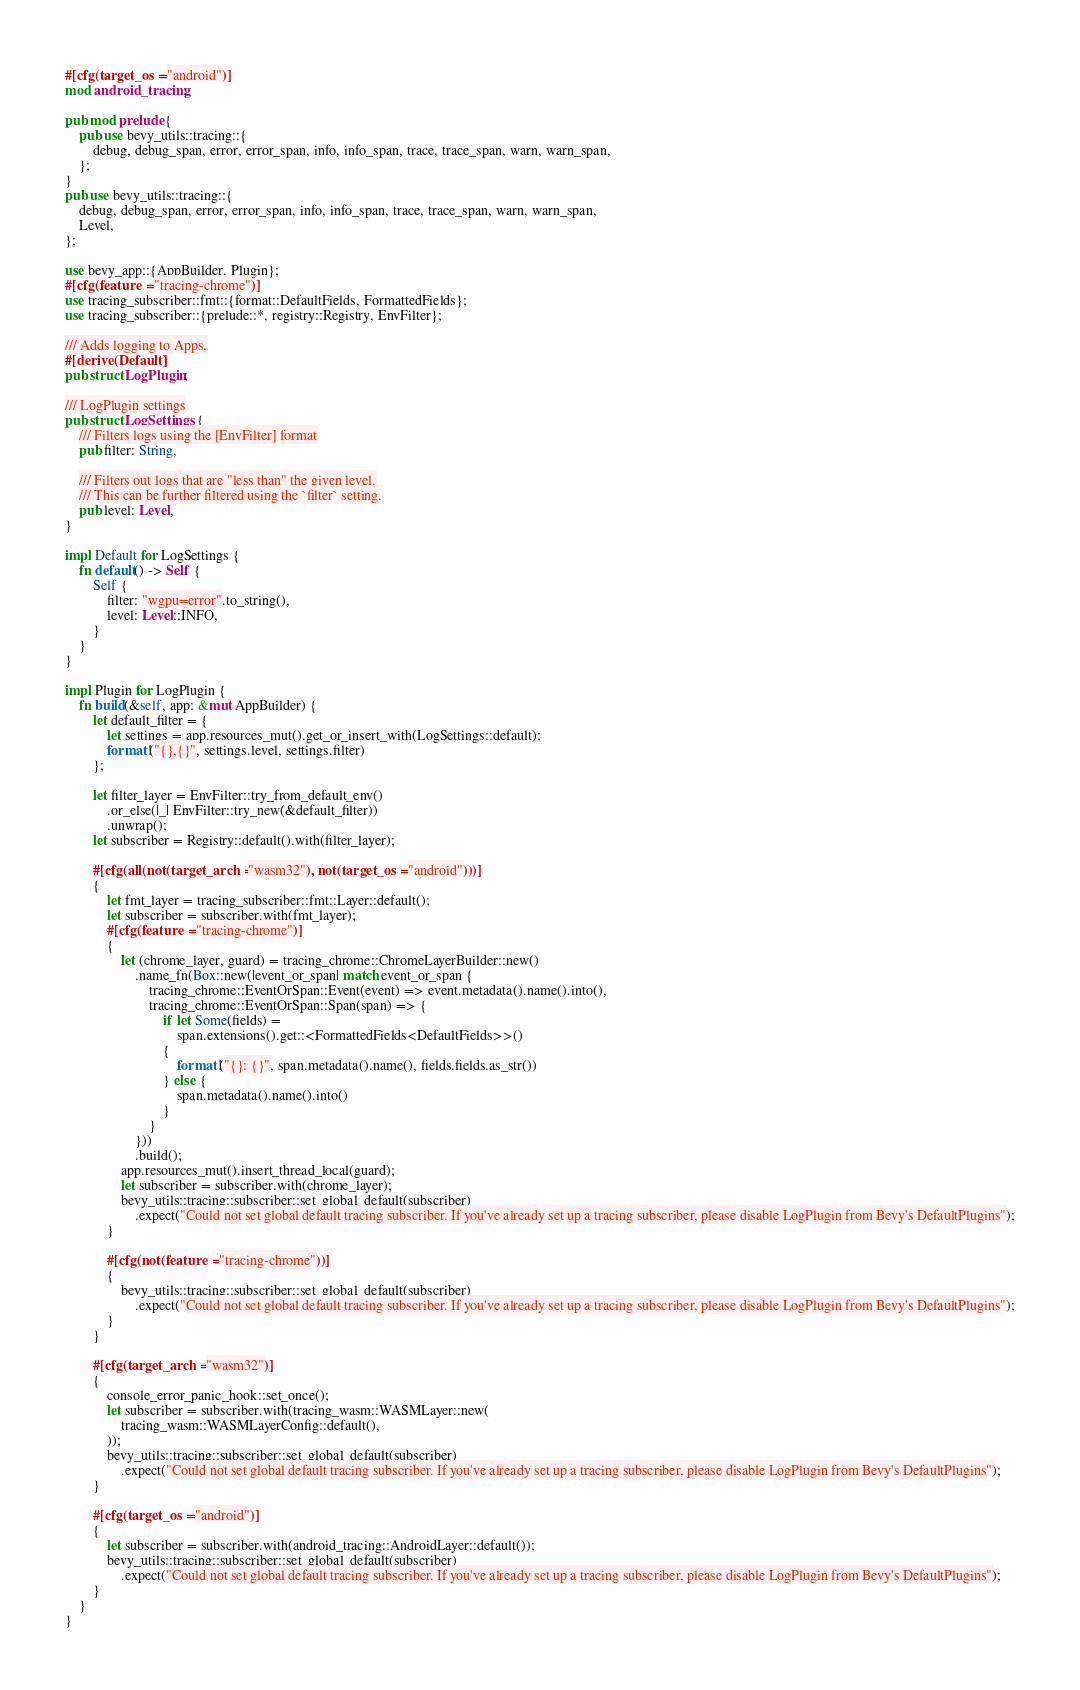<code> <loc_0><loc_0><loc_500><loc_500><_Rust_>#[cfg(target_os = "android")]
mod android_tracing;

pub mod prelude {
    pub use bevy_utils::tracing::{
        debug, debug_span, error, error_span, info, info_span, trace, trace_span, warn, warn_span,
    };
}
pub use bevy_utils::tracing::{
    debug, debug_span, error, error_span, info, info_span, trace, trace_span, warn, warn_span,
    Level,
};

use bevy_app::{AppBuilder, Plugin};
#[cfg(feature = "tracing-chrome")]
use tracing_subscriber::fmt::{format::DefaultFields, FormattedFields};
use tracing_subscriber::{prelude::*, registry::Registry, EnvFilter};

/// Adds logging to Apps.
#[derive(Default)]
pub struct LogPlugin;

/// LogPlugin settings
pub struct LogSettings {
    /// Filters logs using the [EnvFilter] format
    pub filter: String,

    /// Filters out logs that are "less than" the given level.
    /// This can be further filtered using the `filter` setting.
    pub level: Level,
}

impl Default for LogSettings {
    fn default() -> Self {
        Self {
            filter: "wgpu=error".to_string(),
            level: Level::INFO,
        }
    }
}

impl Plugin for LogPlugin {
    fn build(&self, app: &mut AppBuilder) {
        let default_filter = {
            let settings = app.resources_mut().get_or_insert_with(LogSettings::default);
            format!("{},{}", settings.level, settings.filter)
        };

        let filter_layer = EnvFilter::try_from_default_env()
            .or_else(|_| EnvFilter::try_new(&default_filter))
            .unwrap();
        let subscriber = Registry::default().with(filter_layer);

        #[cfg(all(not(target_arch = "wasm32"), not(target_os = "android")))]
        {
            let fmt_layer = tracing_subscriber::fmt::Layer::default();
            let subscriber = subscriber.with(fmt_layer);
            #[cfg(feature = "tracing-chrome")]
            {
                let (chrome_layer, guard) = tracing_chrome::ChromeLayerBuilder::new()
                    .name_fn(Box::new(|event_or_span| match event_or_span {
                        tracing_chrome::EventOrSpan::Event(event) => event.metadata().name().into(),
                        tracing_chrome::EventOrSpan::Span(span) => {
                            if let Some(fields) =
                                span.extensions().get::<FormattedFields<DefaultFields>>()
                            {
                                format!("{}: {}", span.metadata().name(), fields.fields.as_str())
                            } else {
                                span.metadata().name().into()
                            }
                        }
                    }))
                    .build();
                app.resources_mut().insert_thread_local(guard);
                let subscriber = subscriber.with(chrome_layer);
                bevy_utils::tracing::subscriber::set_global_default(subscriber)
                    .expect("Could not set global default tracing subscriber. If you've already set up a tracing subscriber, please disable LogPlugin from Bevy's DefaultPlugins");
            }

            #[cfg(not(feature = "tracing-chrome"))]
            {
                bevy_utils::tracing::subscriber::set_global_default(subscriber)
                    .expect("Could not set global default tracing subscriber. If you've already set up a tracing subscriber, please disable LogPlugin from Bevy's DefaultPlugins");
            }
        }

        #[cfg(target_arch = "wasm32")]
        {
            console_error_panic_hook::set_once();
            let subscriber = subscriber.with(tracing_wasm::WASMLayer::new(
                tracing_wasm::WASMLayerConfig::default(),
            ));
            bevy_utils::tracing::subscriber::set_global_default(subscriber)
                .expect("Could not set global default tracing subscriber. If you've already set up a tracing subscriber, please disable LogPlugin from Bevy's DefaultPlugins");
        }

        #[cfg(target_os = "android")]
        {
            let subscriber = subscriber.with(android_tracing::AndroidLayer::default());
            bevy_utils::tracing::subscriber::set_global_default(subscriber)
                .expect("Could not set global default tracing subscriber. If you've already set up a tracing subscriber, please disable LogPlugin from Bevy's DefaultPlugins");
        }
    }
}
</code> 